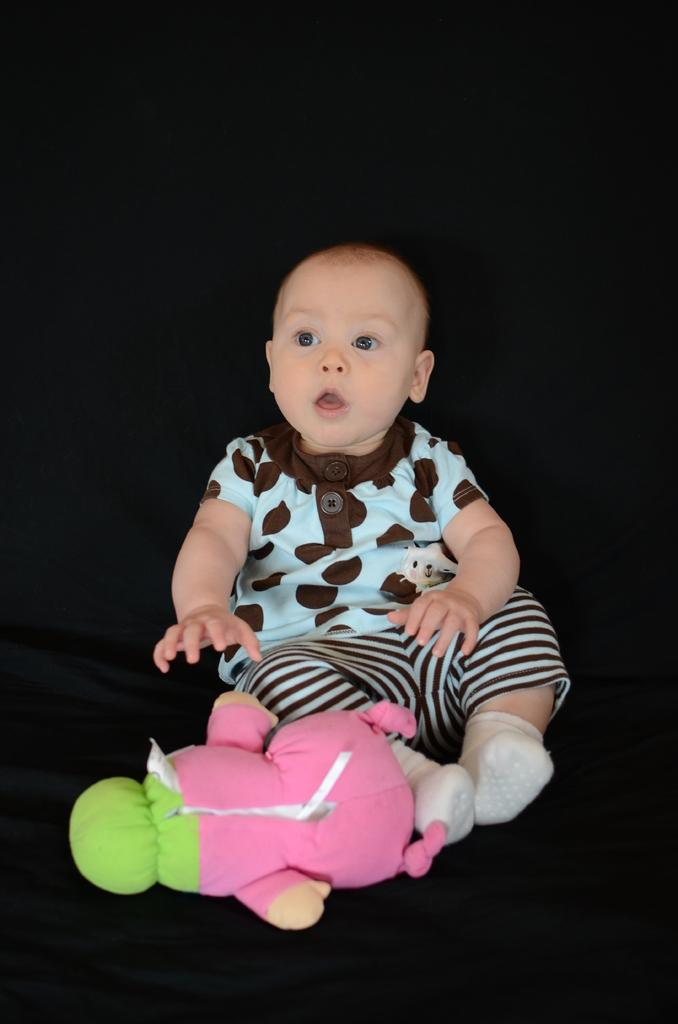What is the main subject of the image? There is a baby in the image. What is the baby sitting on? The baby is sitting on a black color surface. Are there any other objects on the surface with the baby? Yes, there is a doll on the surface. How would you describe the overall color scheme of the image? The background of the image is dark in color. What type of action is the van performing in the image? There is no van present in the image, so it is not possible to answer that question. 